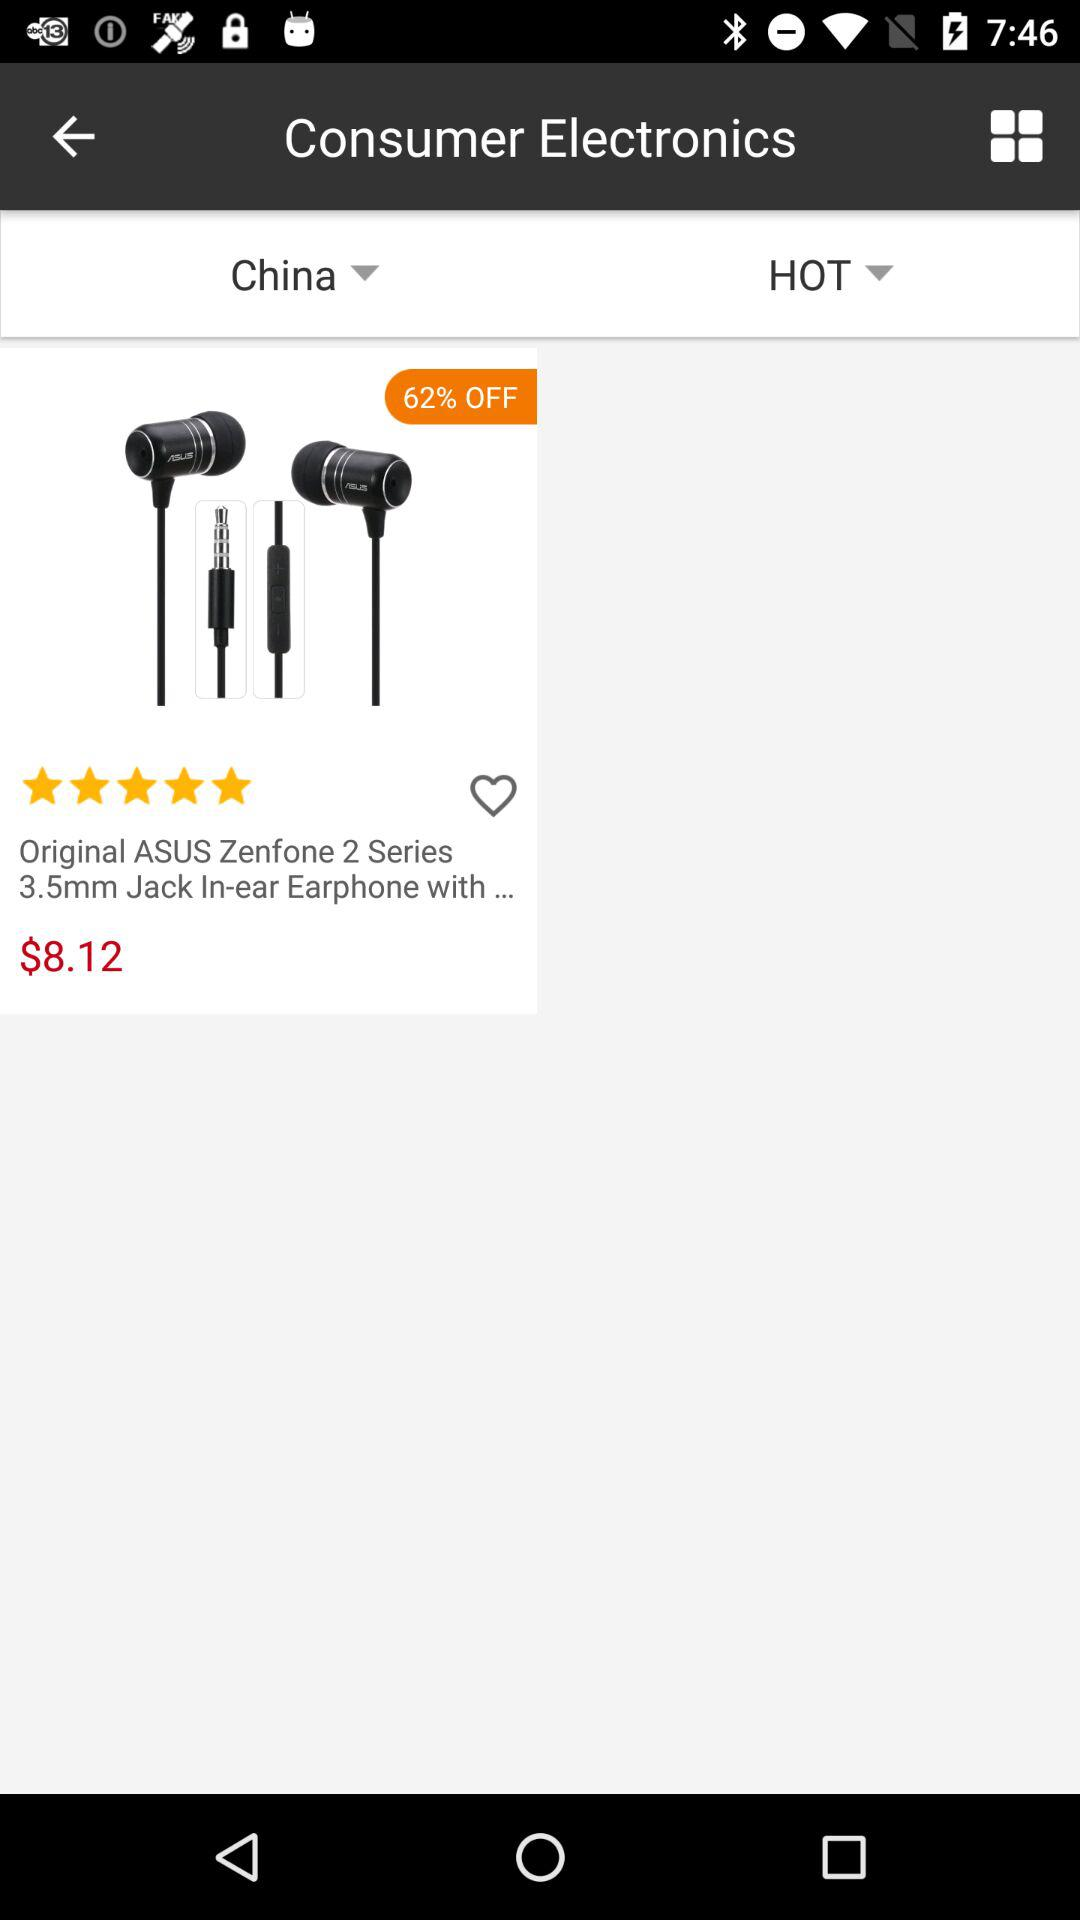What is the price of the item?
Answer the question using a single word or phrase. $8.12 